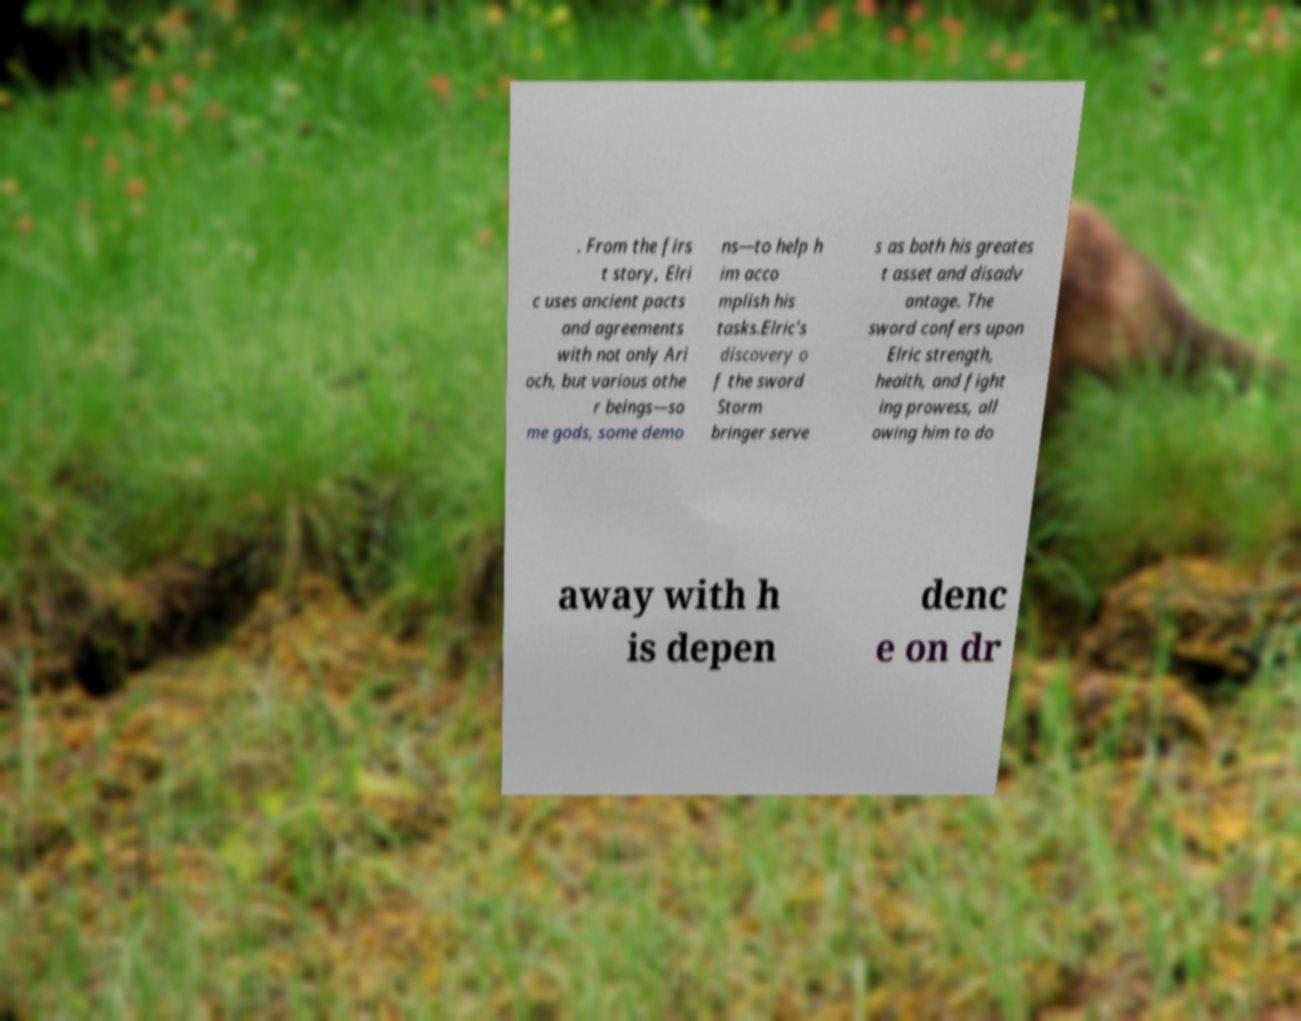Can you accurately transcribe the text from the provided image for me? . From the firs t story, Elri c uses ancient pacts and agreements with not only Ari och, but various othe r beings—so me gods, some demo ns—to help h im acco mplish his tasks.Elric's discovery o f the sword Storm bringer serve s as both his greates t asset and disadv antage. The sword confers upon Elric strength, health, and fight ing prowess, all owing him to do away with h is depen denc e on dr 